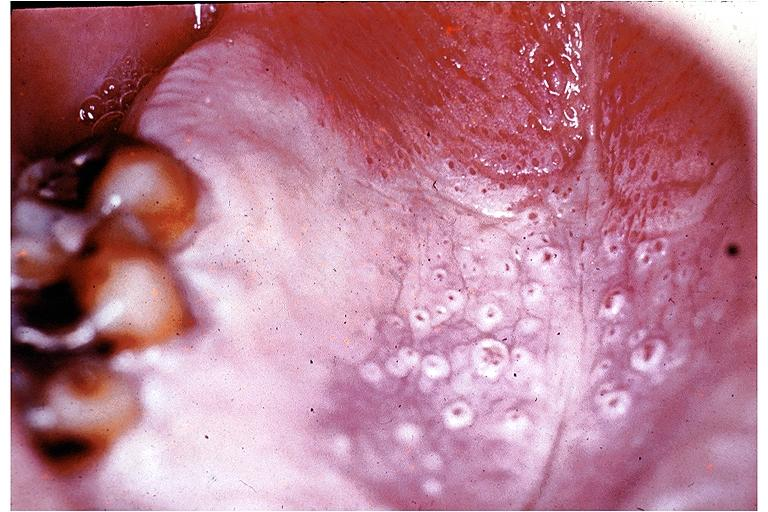what is present?
Answer the question using a single word or phrase. Oral 